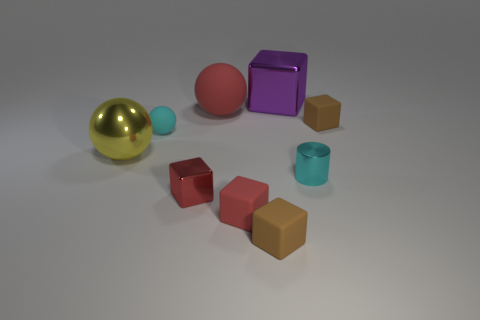What number of yellow things are made of the same material as the cylinder?
Your response must be concise. 1. What color is the tiny matte sphere?
Make the answer very short. Cyan. There is a rubber sphere that is the same size as the purple object; what is its color?
Your answer should be compact. Red. Is there a big metallic thing of the same color as the large shiny sphere?
Your answer should be very brief. No. Does the brown rubber object left of the tiny cyan metallic object have the same shape as the small brown thing right of the purple block?
Provide a succinct answer. Yes. What is the size of the matte sphere that is the same color as the tiny shiny cube?
Your answer should be compact. Large. What number of other objects are there of the same size as the yellow metallic object?
Offer a terse response. 2. Do the tiny rubber sphere and the small metallic thing to the right of the red rubber block have the same color?
Keep it short and to the point. Yes. Is the number of metallic things that are in front of the shiny sphere less than the number of matte things that are on the right side of the large rubber object?
Provide a short and direct response. Yes. There is a thing that is both to the left of the big red rubber object and in front of the cyan cylinder; what color is it?
Provide a succinct answer. Red. 